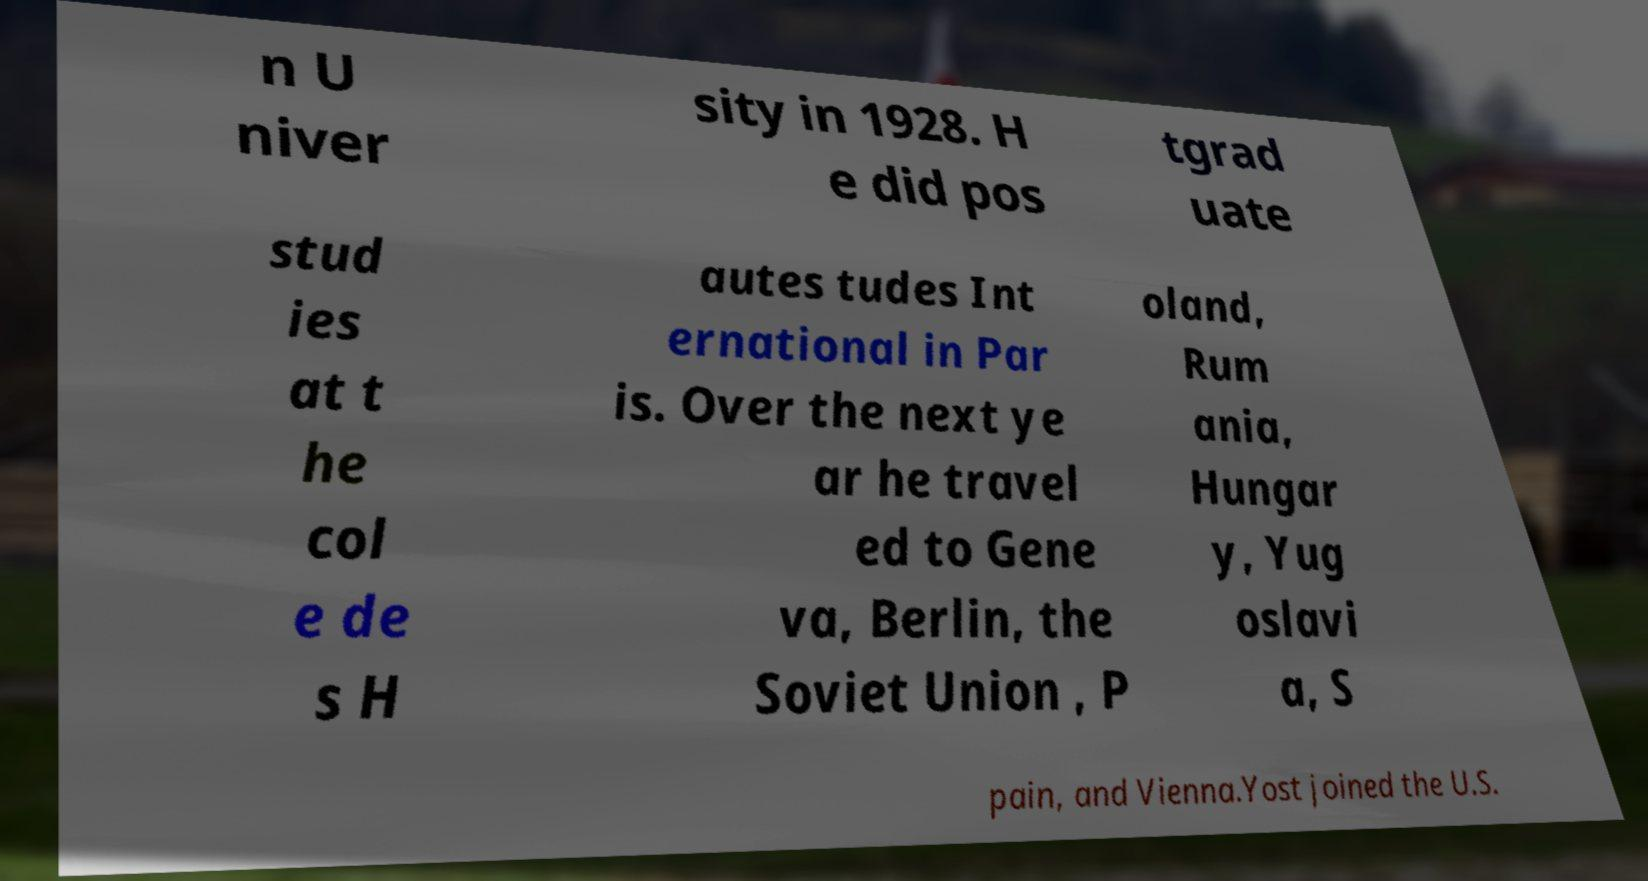Can you accurately transcribe the text from the provided image for me? n U niver sity in 1928. H e did pos tgrad uate stud ies at t he col e de s H autes tudes Int ernational in Par is. Over the next ye ar he travel ed to Gene va, Berlin, the Soviet Union , P oland, Rum ania, Hungar y, Yug oslavi a, S pain, and Vienna.Yost joined the U.S. 